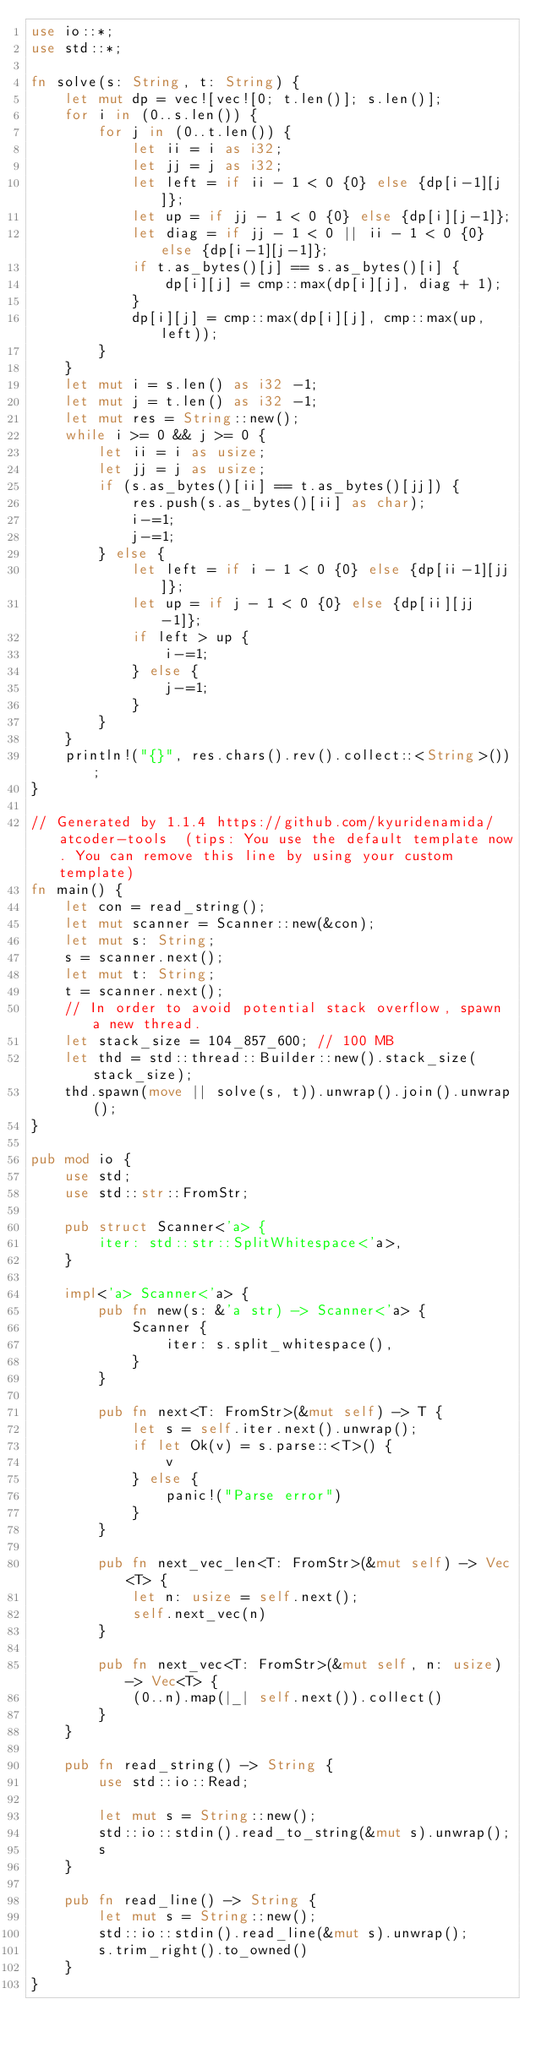Convert code to text. <code><loc_0><loc_0><loc_500><loc_500><_Rust_>use io::*;
use std::*;

fn solve(s: String, t: String) {
    let mut dp = vec![vec![0; t.len()]; s.len()];
    for i in (0..s.len()) {
        for j in (0..t.len()) {
            let ii = i as i32;
            let jj = j as i32;
            let left = if ii - 1 < 0 {0} else {dp[i-1][j]};
            let up = if jj - 1 < 0 {0} else {dp[i][j-1]};
            let diag = if jj - 1 < 0 || ii - 1 < 0 {0} else {dp[i-1][j-1]};
            if t.as_bytes()[j] == s.as_bytes()[i] {
                dp[i][j] = cmp::max(dp[i][j], diag + 1);
            }
            dp[i][j] = cmp::max(dp[i][j], cmp::max(up, left));
        }
    }
    let mut i = s.len() as i32 -1;
    let mut j = t.len() as i32 -1;
    let mut res = String::new();
    while i >= 0 && j >= 0 {
        let ii = i as usize;
        let jj = j as usize;
        if (s.as_bytes()[ii] == t.as_bytes()[jj]) {
            res.push(s.as_bytes()[ii] as char);
            i-=1;
            j-=1;
        } else {
            let left = if i - 1 < 0 {0} else {dp[ii-1][jj]};
            let up = if j - 1 < 0 {0} else {dp[ii][jj-1]};
            if left > up {
                i-=1;
            } else {
                j-=1;
            }
        }
    }
    println!("{}", res.chars().rev().collect::<String>());
}

// Generated by 1.1.4 https://github.com/kyuridenamida/atcoder-tools  (tips: You use the default template now. You can remove this line by using your custom template)
fn main() {
    let con = read_string();
    let mut scanner = Scanner::new(&con);
    let mut s: String;
    s = scanner.next();
    let mut t: String;
    t = scanner.next();
    // In order to avoid potential stack overflow, spawn a new thread.
    let stack_size = 104_857_600; // 100 MB
    let thd = std::thread::Builder::new().stack_size(stack_size);
    thd.spawn(move || solve(s, t)).unwrap().join().unwrap();
}

pub mod io {
    use std;
    use std::str::FromStr;

    pub struct Scanner<'a> {
        iter: std::str::SplitWhitespace<'a>,
    }

    impl<'a> Scanner<'a> {
        pub fn new(s: &'a str) -> Scanner<'a> {
            Scanner {
                iter: s.split_whitespace(),
            }
        }

        pub fn next<T: FromStr>(&mut self) -> T {
            let s = self.iter.next().unwrap();
            if let Ok(v) = s.parse::<T>() {
                v
            } else {
                panic!("Parse error")
            }
        }

        pub fn next_vec_len<T: FromStr>(&mut self) -> Vec<T> {
            let n: usize = self.next();
            self.next_vec(n)
        }

        pub fn next_vec<T: FromStr>(&mut self, n: usize) -> Vec<T> {
            (0..n).map(|_| self.next()).collect()
        }
    }

    pub fn read_string() -> String {
        use std::io::Read;

        let mut s = String::new();
        std::io::stdin().read_to_string(&mut s).unwrap();
        s
    }

    pub fn read_line() -> String {
        let mut s = String::new();
        std::io::stdin().read_line(&mut s).unwrap();
        s.trim_right().to_owned()
    }
}
</code> 